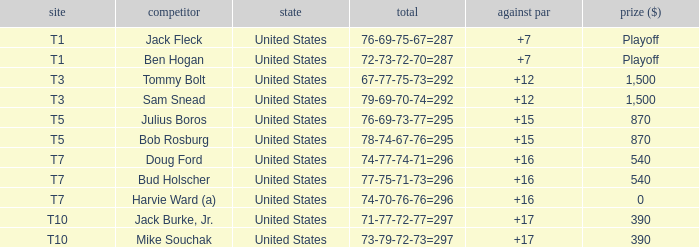What is average to par when Bud Holscher is the player? 16.0. 